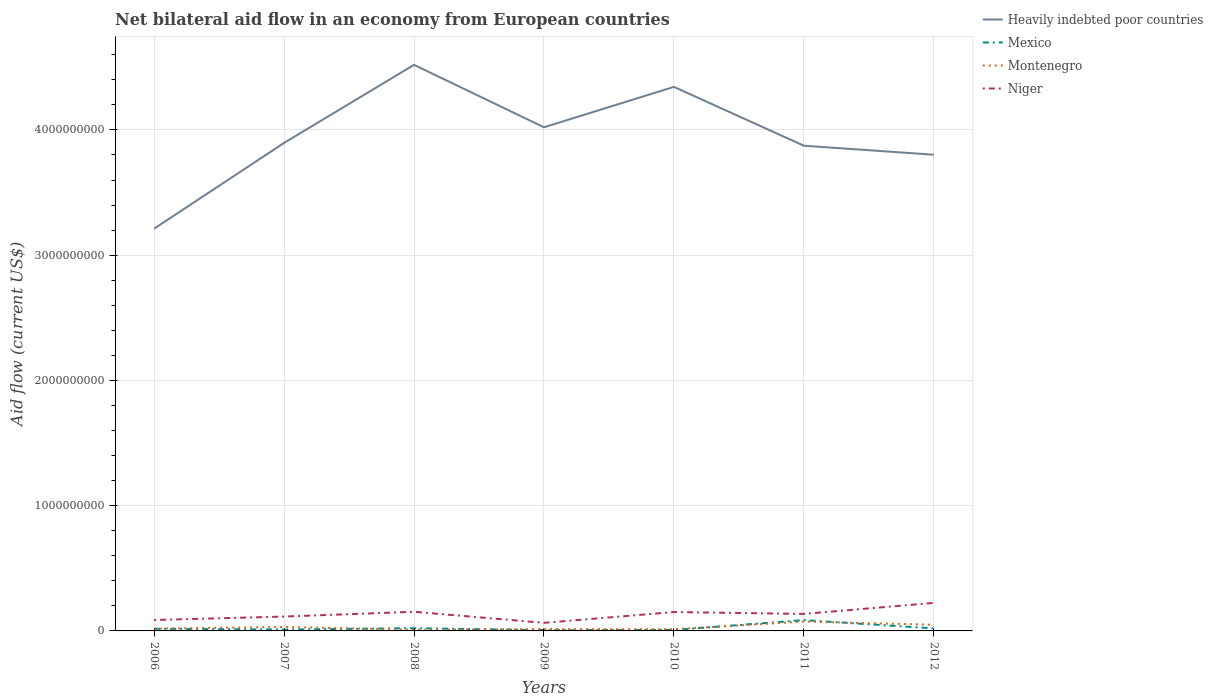Across all years, what is the maximum net bilateral aid flow in Heavily indebted poor countries?
Your answer should be compact. 3.21e+09. What is the total net bilateral aid flow in Niger in the graph?
Offer a very short reply. 8.84e+07. What is the difference between the highest and the second highest net bilateral aid flow in Montenegro?
Make the answer very short. 6.52e+07. What is the difference between the highest and the lowest net bilateral aid flow in Montenegro?
Your response must be concise. 3. Is the net bilateral aid flow in Heavily indebted poor countries strictly greater than the net bilateral aid flow in Niger over the years?
Make the answer very short. No. Does the graph contain any zero values?
Your answer should be very brief. No. Where does the legend appear in the graph?
Your answer should be compact. Top right. How many legend labels are there?
Make the answer very short. 4. How are the legend labels stacked?
Provide a succinct answer. Vertical. What is the title of the graph?
Ensure brevity in your answer.  Net bilateral aid flow in an economy from European countries. Does "Cabo Verde" appear as one of the legend labels in the graph?
Give a very brief answer. No. What is the Aid flow (current US$) in Heavily indebted poor countries in 2006?
Make the answer very short. 3.21e+09. What is the Aid flow (current US$) in Mexico in 2006?
Give a very brief answer. 1.73e+07. What is the Aid flow (current US$) of Montenegro in 2006?
Your answer should be compact. 1.81e+07. What is the Aid flow (current US$) in Niger in 2006?
Your answer should be compact. 8.72e+07. What is the Aid flow (current US$) of Heavily indebted poor countries in 2007?
Your answer should be compact. 3.90e+09. What is the Aid flow (current US$) in Mexico in 2007?
Offer a terse response. 1.09e+07. What is the Aid flow (current US$) in Montenegro in 2007?
Offer a very short reply. 3.16e+07. What is the Aid flow (current US$) of Niger in 2007?
Give a very brief answer. 1.15e+08. What is the Aid flow (current US$) in Heavily indebted poor countries in 2008?
Your answer should be very brief. 4.52e+09. What is the Aid flow (current US$) in Mexico in 2008?
Give a very brief answer. 2.17e+07. What is the Aid flow (current US$) of Montenegro in 2008?
Ensure brevity in your answer.  9.50e+06. What is the Aid flow (current US$) in Niger in 2008?
Make the answer very short. 1.53e+08. What is the Aid flow (current US$) of Heavily indebted poor countries in 2009?
Keep it short and to the point. 4.02e+09. What is the Aid flow (current US$) of Mexico in 2009?
Your answer should be very brief. 6.08e+06. What is the Aid flow (current US$) of Montenegro in 2009?
Give a very brief answer. 1.50e+07. What is the Aid flow (current US$) of Niger in 2009?
Provide a short and direct response. 6.44e+07. What is the Aid flow (current US$) of Heavily indebted poor countries in 2010?
Your answer should be very brief. 4.34e+09. What is the Aid flow (current US$) of Mexico in 2010?
Your answer should be compact. 7.51e+06. What is the Aid flow (current US$) of Montenegro in 2010?
Your answer should be very brief. 1.37e+07. What is the Aid flow (current US$) of Niger in 2010?
Provide a short and direct response. 1.51e+08. What is the Aid flow (current US$) in Heavily indebted poor countries in 2011?
Keep it short and to the point. 3.87e+09. What is the Aid flow (current US$) in Mexico in 2011?
Ensure brevity in your answer.  8.64e+07. What is the Aid flow (current US$) of Montenegro in 2011?
Give a very brief answer. 7.47e+07. What is the Aid flow (current US$) of Niger in 2011?
Make the answer very short. 1.36e+08. What is the Aid flow (current US$) in Heavily indebted poor countries in 2012?
Make the answer very short. 3.80e+09. What is the Aid flow (current US$) of Mexico in 2012?
Make the answer very short. 2.01e+07. What is the Aid flow (current US$) in Montenegro in 2012?
Offer a terse response. 4.91e+07. What is the Aid flow (current US$) in Niger in 2012?
Make the answer very short. 2.24e+08. Across all years, what is the maximum Aid flow (current US$) in Heavily indebted poor countries?
Provide a succinct answer. 4.52e+09. Across all years, what is the maximum Aid flow (current US$) in Mexico?
Keep it short and to the point. 8.64e+07. Across all years, what is the maximum Aid flow (current US$) in Montenegro?
Give a very brief answer. 7.47e+07. Across all years, what is the maximum Aid flow (current US$) of Niger?
Keep it short and to the point. 2.24e+08. Across all years, what is the minimum Aid flow (current US$) in Heavily indebted poor countries?
Provide a succinct answer. 3.21e+09. Across all years, what is the minimum Aid flow (current US$) of Mexico?
Ensure brevity in your answer.  6.08e+06. Across all years, what is the minimum Aid flow (current US$) of Montenegro?
Ensure brevity in your answer.  9.50e+06. Across all years, what is the minimum Aid flow (current US$) of Niger?
Give a very brief answer. 6.44e+07. What is the total Aid flow (current US$) in Heavily indebted poor countries in the graph?
Offer a very short reply. 2.77e+1. What is the total Aid flow (current US$) in Mexico in the graph?
Your answer should be very brief. 1.70e+08. What is the total Aid flow (current US$) of Montenegro in the graph?
Provide a short and direct response. 2.12e+08. What is the total Aid flow (current US$) in Niger in the graph?
Make the answer very short. 9.30e+08. What is the difference between the Aid flow (current US$) of Heavily indebted poor countries in 2006 and that in 2007?
Your response must be concise. -6.85e+08. What is the difference between the Aid flow (current US$) of Mexico in 2006 and that in 2007?
Make the answer very short. 6.42e+06. What is the difference between the Aid flow (current US$) in Montenegro in 2006 and that in 2007?
Give a very brief answer. -1.34e+07. What is the difference between the Aid flow (current US$) of Niger in 2006 and that in 2007?
Your answer should be compact. -2.75e+07. What is the difference between the Aid flow (current US$) in Heavily indebted poor countries in 2006 and that in 2008?
Offer a very short reply. -1.31e+09. What is the difference between the Aid flow (current US$) in Mexico in 2006 and that in 2008?
Your answer should be very brief. -4.39e+06. What is the difference between the Aid flow (current US$) in Montenegro in 2006 and that in 2008?
Offer a terse response. 8.63e+06. What is the difference between the Aid flow (current US$) in Niger in 2006 and that in 2008?
Keep it short and to the point. -6.57e+07. What is the difference between the Aid flow (current US$) in Heavily indebted poor countries in 2006 and that in 2009?
Offer a terse response. -8.09e+08. What is the difference between the Aid flow (current US$) of Mexico in 2006 and that in 2009?
Offer a terse response. 1.12e+07. What is the difference between the Aid flow (current US$) of Montenegro in 2006 and that in 2009?
Keep it short and to the point. 3.16e+06. What is the difference between the Aid flow (current US$) in Niger in 2006 and that in 2009?
Offer a terse response. 2.28e+07. What is the difference between the Aid flow (current US$) of Heavily indebted poor countries in 2006 and that in 2010?
Offer a very short reply. -1.13e+09. What is the difference between the Aid flow (current US$) in Mexico in 2006 and that in 2010?
Your response must be concise. 9.80e+06. What is the difference between the Aid flow (current US$) of Montenegro in 2006 and that in 2010?
Your answer should be very brief. 4.43e+06. What is the difference between the Aid flow (current US$) in Niger in 2006 and that in 2010?
Your answer should be compact. -6.36e+07. What is the difference between the Aid flow (current US$) in Heavily indebted poor countries in 2006 and that in 2011?
Offer a terse response. -6.62e+08. What is the difference between the Aid flow (current US$) in Mexico in 2006 and that in 2011?
Your answer should be compact. -6.91e+07. What is the difference between the Aid flow (current US$) in Montenegro in 2006 and that in 2011?
Make the answer very short. -5.66e+07. What is the difference between the Aid flow (current US$) in Niger in 2006 and that in 2011?
Provide a succinct answer. -4.85e+07. What is the difference between the Aid flow (current US$) in Heavily indebted poor countries in 2006 and that in 2012?
Your answer should be compact. -5.90e+08. What is the difference between the Aid flow (current US$) in Mexico in 2006 and that in 2012?
Provide a succinct answer. -2.81e+06. What is the difference between the Aid flow (current US$) of Montenegro in 2006 and that in 2012?
Your answer should be compact. -3.10e+07. What is the difference between the Aid flow (current US$) of Niger in 2006 and that in 2012?
Keep it short and to the point. -1.37e+08. What is the difference between the Aid flow (current US$) in Heavily indebted poor countries in 2007 and that in 2008?
Provide a succinct answer. -6.23e+08. What is the difference between the Aid flow (current US$) in Mexico in 2007 and that in 2008?
Give a very brief answer. -1.08e+07. What is the difference between the Aid flow (current US$) in Montenegro in 2007 and that in 2008?
Make the answer very short. 2.21e+07. What is the difference between the Aid flow (current US$) in Niger in 2007 and that in 2008?
Give a very brief answer. -3.82e+07. What is the difference between the Aid flow (current US$) of Heavily indebted poor countries in 2007 and that in 2009?
Ensure brevity in your answer.  -1.25e+08. What is the difference between the Aid flow (current US$) of Mexico in 2007 and that in 2009?
Make the answer very short. 4.81e+06. What is the difference between the Aid flow (current US$) of Montenegro in 2007 and that in 2009?
Offer a terse response. 1.66e+07. What is the difference between the Aid flow (current US$) of Niger in 2007 and that in 2009?
Keep it short and to the point. 5.03e+07. What is the difference between the Aid flow (current US$) of Heavily indebted poor countries in 2007 and that in 2010?
Your response must be concise. -4.47e+08. What is the difference between the Aid flow (current US$) in Mexico in 2007 and that in 2010?
Keep it short and to the point. 3.38e+06. What is the difference between the Aid flow (current US$) of Montenegro in 2007 and that in 2010?
Keep it short and to the point. 1.79e+07. What is the difference between the Aid flow (current US$) of Niger in 2007 and that in 2010?
Give a very brief answer. -3.61e+07. What is the difference between the Aid flow (current US$) in Heavily indebted poor countries in 2007 and that in 2011?
Provide a succinct answer. 2.26e+07. What is the difference between the Aid flow (current US$) in Mexico in 2007 and that in 2011?
Make the answer very short. -7.55e+07. What is the difference between the Aid flow (current US$) in Montenegro in 2007 and that in 2011?
Your answer should be very brief. -4.32e+07. What is the difference between the Aid flow (current US$) in Niger in 2007 and that in 2011?
Keep it short and to the point. -2.10e+07. What is the difference between the Aid flow (current US$) of Heavily indebted poor countries in 2007 and that in 2012?
Keep it short and to the point. 9.45e+07. What is the difference between the Aid flow (current US$) in Mexico in 2007 and that in 2012?
Ensure brevity in your answer.  -9.23e+06. What is the difference between the Aid flow (current US$) of Montenegro in 2007 and that in 2012?
Provide a short and direct response. -1.76e+07. What is the difference between the Aid flow (current US$) of Niger in 2007 and that in 2012?
Provide a short and direct response. -1.09e+08. What is the difference between the Aid flow (current US$) in Heavily indebted poor countries in 2008 and that in 2009?
Offer a very short reply. 4.98e+08. What is the difference between the Aid flow (current US$) of Mexico in 2008 and that in 2009?
Offer a very short reply. 1.56e+07. What is the difference between the Aid flow (current US$) of Montenegro in 2008 and that in 2009?
Offer a terse response. -5.47e+06. What is the difference between the Aid flow (current US$) in Niger in 2008 and that in 2009?
Your answer should be very brief. 8.84e+07. What is the difference between the Aid flow (current US$) of Heavily indebted poor countries in 2008 and that in 2010?
Keep it short and to the point. 1.76e+08. What is the difference between the Aid flow (current US$) in Mexico in 2008 and that in 2010?
Offer a terse response. 1.42e+07. What is the difference between the Aid flow (current US$) of Montenegro in 2008 and that in 2010?
Ensure brevity in your answer.  -4.20e+06. What is the difference between the Aid flow (current US$) in Niger in 2008 and that in 2010?
Provide a succinct answer. 2.10e+06. What is the difference between the Aid flow (current US$) in Heavily indebted poor countries in 2008 and that in 2011?
Provide a short and direct response. 6.46e+08. What is the difference between the Aid flow (current US$) of Mexico in 2008 and that in 2011?
Provide a short and direct response. -6.47e+07. What is the difference between the Aid flow (current US$) of Montenegro in 2008 and that in 2011?
Your answer should be compact. -6.52e+07. What is the difference between the Aid flow (current US$) of Niger in 2008 and that in 2011?
Your answer should be compact. 1.72e+07. What is the difference between the Aid flow (current US$) in Heavily indebted poor countries in 2008 and that in 2012?
Your response must be concise. 7.18e+08. What is the difference between the Aid flow (current US$) in Mexico in 2008 and that in 2012?
Your response must be concise. 1.58e+06. What is the difference between the Aid flow (current US$) of Montenegro in 2008 and that in 2012?
Provide a short and direct response. -3.96e+07. What is the difference between the Aid flow (current US$) in Niger in 2008 and that in 2012?
Keep it short and to the point. -7.10e+07. What is the difference between the Aid flow (current US$) of Heavily indebted poor countries in 2009 and that in 2010?
Ensure brevity in your answer.  -3.23e+08. What is the difference between the Aid flow (current US$) in Mexico in 2009 and that in 2010?
Offer a very short reply. -1.43e+06. What is the difference between the Aid flow (current US$) in Montenegro in 2009 and that in 2010?
Your answer should be compact. 1.27e+06. What is the difference between the Aid flow (current US$) in Niger in 2009 and that in 2010?
Keep it short and to the point. -8.64e+07. What is the difference between the Aid flow (current US$) of Heavily indebted poor countries in 2009 and that in 2011?
Make the answer very short. 1.47e+08. What is the difference between the Aid flow (current US$) of Mexico in 2009 and that in 2011?
Give a very brief answer. -8.03e+07. What is the difference between the Aid flow (current US$) in Montenegro in 2009 and that in 2011?
Give a very brief answer. -5.98e+07. What is the difference between the Aid flow (current US$) in Niger in 2009 and that in 2011?
Make the answer very short. -7.13e+07. What is the difference between the Aid flow (current US$) in Heavily indebted poor countries in 2009 and that in 2012?
Your answer should be compact. 2.19e+08. What is the difference between the Aid flow (current US$) of Mexico in 2009 and that in 2012?
Your answer should be compact. -1.40e+07. What is the difference between the Aid flow (current US$) in Montenegro in 2009 and that in 2012?
Give a very brief answer. -3.42e+07. What is the difference between the Aid flow (current US$) in Niger in 2009 and that in 2012?
Your answer should be compact. -1.59e+08. What is the difference between the Aid flow (current US$) in Heavily indebted poor countries in 2010 and that in 2011?
Ensure brevity in your answer.  4.70e+08. What is the difference between the Aid flow (current US$) of Mexico in 2010 and that in 2011?
Give a very brief answer. -7.89e+07. What is the difference between the Aid flow (current US$) of Montenegro in 2010 and that in 2011?
Offer a very short reply. -6.10e+07. What is the difference between the Aid flow (current US$) in Niger in 2010 and that in 2011?
Keep it short and to the point. 1.51e+07. What is the difference between the Aid flow (current US$) of Heavily indebted poor countries in 2010 and that in 2012?
Offer a very short reply. 5.42e+08. What is the difference between the Aid flow (current US$) of Mexico in 2010 and that in 2012?
Make the answer very short. -1.26e+07. What is the difference between the Aid flow (current US$) in Montenegro in 2010 and that in 2012?
Your answer should be very brief. -3.54e+07. What is the difference between the Aid flow (current US$) in Niger in 2010 and that in 2012?
Give a very brief answer. -7.30e+07. What is the difference between the Aid flow (current US$) in Heavily indebted poor countries in 2011 and that in 2012?
Your answer should be very brief. 7.20e+07. What is the difference between the Aid flow (current US$) of Mexico in 2011 and that in 2012?
Offer a terse response. 6.63e+07. What is the difference between the Aid flow (current US$) in Montenegro in 2011 and that in 2012?
Keep it short and to the point. 2.56e+07. What is the difference between the Aid flow (current US$) of Niger in 2011 and that in 2012?
Give a very brief answer. -8.81e+07. What is the difference between the Aid flow (current US$) of Heavily indebted poor countries in 2006 and the Aid flow (current US$) of Mexico in 2007?
Offer a terse response. 3.20e+09. What is the difference between the Aid flow (current US$) of Heavily indebted poor countries in 2006 and the Aid flow (current US$) of Montenegro in 2007?
Ensure brevity in your answer.  3.18e+09. What is the difference between the Aid flow (current US$) in Heavily indebted poor countries in 2006 and the Aid flow (current US$) in Niger in 2007?
Give a very brief answer. 3.10e+09. What is the difference between the Aid flow (current US$) of Mexico in 2006 and the Aid flow (current US$) of Montenegro in 2007?
Your answer should be compact. -1.43e+07. What is the difference between the Aid flow (current US$) of Mexico in 2006 and the Aid flow (current US$) of Niger in 2007?
Provide a short and direct response. -9.74e+07. What is the difference between the Aid flow (current US$) in Montenegro in 2006 and the Aid flow (current US$) in Niger in 2007?
Provide a short and direct response. -9.66e+07. What is the difference between the Aid flow (current US$) of Heavily indebted poor countries in 2006 and the Aid flow (current US$) of Mexico in 2008?
Offer a very short reply. 3.19e+09. What is the difference between the Aid flow (current US$) of Heavily indebted poor countries in 2006 and the Aid flow (current US$) of Montenegro in 2008?
Your answer should be compact. 3.20e+09. What is the difference between the Aid flow (current US$) of Heavily indebted poor countries in 2006 and the Aid flow (current US$) of Niger in 2008?
Offer a terse response. 3.06e+09. What is the difference between the Aid flow (current US$) in Mexico in 2006 and the Aid flow (current US$) in Montenegro in 2008?
Keep it short and to the point. 7.81e+06. What is the difference between the Aid flow (current US$) in Mexico in 2006 and the Aid flow (current US$) in Niger in 2008?
Your answer should be very brief. -1.36e+08. What is the difference between the Aid flow (current US$) in Montenegro in 2006 and the Aid flow (current US$) in Niger in 2008?
Offer a very short reply. -1.35e+08. What is the difference between the Aid flow (current US$) in Heavily indebted poor countries in 2006 and the Aid flow (current US$) in Mexico in 2009?
Give a very brief answer. 3.21e+09. What is the difference between the Aid flow (current US$) in Heavily indebted poor countries in 2006 and the Aid flow (current US$) in Montenegro in 2009?
Give a very brief answer. 3.20e+09. What is the difference between the Aid flow (current US$) in Heavily indebted poor countries in 2006 and the Aid flow (current US$) in Niger in 2009?
Give a very brief answer. 3.15e+09. What is the difference between the Aid flow (current US$) in Mexico in 2006 and the Aid flow (current US$) in Montenegro in 2009?
Your answer should be very brief. 2.34e+06. What is the difference between the Aid flow (current US$) in Mexico in 2006 and the Aid flow (current US$) in Niger in 2009?
Give a very brief answer. -4.71e+07. What is the difference between the Aid flow (current US$) of Montenegro in 2006 and the Aid flow (current US$) of Niger in 2009?
Ensure brevity in your answer.  -4.63e+07. What is the difference between the Aid flow (current US$) in Heavily indebted poor countries in 2006 and the Aid flow (current US$) in Mexico in 2010?
Offer a very short reply. 3.20e+09. What is the difference between the Aid flow (current US$) of Heavily indebted poor countries in 2006 and the Aid flow (current US$) of Montenegro in 2010?
Provide a succinct answer. 3.20e+09. What is the difference between the Aid flow (current US$) of Heavily indebted poor countries in 2006 and the Aid flow (current US$) of Niger in 2010?
Provide a short and direct response. 3.06e+09. What is the difference between the Aid flow (current US$) of Mexico in 2006 and the Aid flow (current US$) of Montenegro in 2010?
Offer a terse response. 3.61e+06. What is the difference between the Aid flow (current US$) in Mexico in 2006 and the Aid flow (current US$) in Niger in 2010?
Keep it short and to the point. -1.33e+08. What is the difference between the Aid flow (current US$) in Montenegro in 2006 and the Aid flow (current US$) in Niger in 2010?
Offer a very short reply. -1.33e+08. What is the difference between the Aid flow (current US$) in Heavily indebted poor countries in 2006 and the Aid flow (current US$) in Mexico in 2011?
Provide a short and direct response. 3.13e+09. What is the difference between the Aid flow (current US$) in Heavily indebted poor countries in 2006 and the Aid flow (current US$) in Montenegro in 2011?
Make the answer very short. 3.14e+09. What is the difference between the Aid flow (current US$) of Heavily indebted poor countries in 2006 and the Aid flow (current US$) of Niger in 2011?
Provide a succinct answer. 3.08e+09. What is the difference between the Aid flow (current US$) in Mexico in 2006 and the Aid flow (current US$) in Montenegro in 2011?
Keep it short and to the point. -5.74e+07. What is the difference between the Aid flow (current US$) of Mexico in 2006 and the Aid flow (current US$) of Niger in 2011?
Your answer should be compact. -1.18e+08. What is the difference between the Aid flow (current US$) in Montenegro in 2006 and the Aid flow (current US$) in Niger in 2011?
Make the answer very short. -1.18e+08. What is the difference between the Aid flow (current US$) in Heavily indebted poor countries in 2006 and the Aid flow (current US$) in Mexico in 2012?
Give a very brief answer. 3.19e+09. What is the difference between the Aid flow (current US$) of Heavily indebted poor countries in 2006 and the Aid flow (current US$) of Montenegro in 2012?
Offer a terse response. 3.16e+09. What is the difference between the Aid flow (current US$) of Heavily indebted poor countries in 2006 and the Aid flow (current US$) of Niger in 2012?
Give a very brief answer. 2.99e+09. What is the difference between the Aid flow (current US$) of Mexico in 2006 and the Aid flow (current US$) of Montenegro in 2012?
Your answer should be very brief. -3.18e+07. What is the difference between the Aid flow (current US$) in Mexico in 2006 and the Aid flow (current US$) in Niger in 2012?
Provide a short and direct response. -2.07e+08. What is the difference between the Aid flow (current US$) of Montenegro in 2006 and the Aid flow (current US$) of Niger in 2012?
Your response must be concise. -2.06e+08. What is the difference between the Aid flow (current US$) of Heavily indebted poor countries in 2007 and the Aid flow (current US$) of Mexico in 2008?
Provide a succinct answer. 3.87e+09. What is the difference between the Aid flow (current US$) of Heavily indebted poor countries in 2007 and the Aid flow (current US$) of Montenegro in 2008?
Offer a terse response. 3.89e+09. What is the difference between the Aid flow (current US$) in Heavily indebted poor countries in 2007 and the Aid flow (current US$) in Niger in 2008?
Your answer should be very brief. 3.74e+09. What is the difference between the Aid flow (current US$) in Mexico in 2007 and the Aid flow (current US$) in Montenegro in 2008?
Offer a very short reply. 1.39e+06. What is the difference between the Aid flow (current US$) in Mexico in 2007 and the Aid flow (current US$) in Niger in 2008?
Keep it short and to the point. -1.42e+08. What is the difference between the Aid flow (current US$) of Montenegro in 2007 and the Aid flow (current US$) of Niger in 2008?
Provide a succinct answer. -1.21e+08. What is the difference between the Aid flow (current US$) in Heavily indebted poor countries in 2007 and the Aid flow (current US$) in Mexico in 2009?
Give a very brief answer. 3.89e+09. What is the difference between the Aid flow (current US$) in Heavily indebted poor countries in 2007 and the Aid flow (current US$) in Montenegro in 2009?
Provide a short and direct response. 3.88e+09. What is the difference between the Aid flow (current US$) of Heavily indebted poor countries in 2007 and the Aid flow (current US$) of Niger in 2009?
Provide a short and direct response. 3.83e+09. What is the difference between the Aid flow (current US$) in Mexico in 2007 and the Aid flow (current US$) in Montenegro in 2009?
Offer a very short reply. -4.08e+06. What is the difference between the Aid flow (current US$) in Mexico in 2007 and the Aid flow (current US$) in Niger in 2009?
Your answer should be very brief. -5.36e+07. What is the difference between the Aid flow (current US$) of Montenegro in 2007 and the Aid flow (current US$) of Niger in 2009?
Provide a short and direct response. -3.29e+07. What is the difference between the Aid flow (current US$) of Heavily indebted poor countries in 2007 and the Aid flow (current US$) of Mexico in 2010?
Ensure brevity in your answer.  3.89e+09. What is the difference between the Aid flow (current US$) of Heavily indebted poor countries in 2007 and the Aid flow (current US$) of Montenegro in 2010?
Keep it short and to the point. 3.88e+09. What is the difference between the Aid flow (current US$) in Heavily indebted poor countries in 2007 and the Aid flow (current US$) in Niger in 2010?
Offer a terse response. 3.75e+09. What is the difference between the Aid flow (current US$) in Mexico in 2007 and the Aid flow (current US$) in Montenegro in 2010?
Offer a terse response. -2.81e+06. What is the difference between the Aid flow (current US$) of Mexico in 2007 and the Aid flow (current US$) of Niger in 2010?
Your answer should be very brief. -1.40e+08. What is the difference between the Aid flow (current US$) of Montenegro in 2007 and the Aid flow (current US$) of Niger in 2010?
Keep it short and to the point. -1.19e+08. What is the difference between the Aid flow (current US$) in Heavily indebted poor countries in 2007 and the Aid flow (current US$) in Mexico in 2011?
Your response must be concise. 3.81e+09. What is the difference between the Aid flow (current US$) of Heavily indebted poor countries in 2007 and the Aid flow (current US$) of Montenegro in 2011?
Provide a succinct answer. 3.82e+09. What is the difference between the Aid flow (current US$) of Heavily indebted poor countries in 2007 and the Aid flow (current US$) of Niger in 2011?
Make the answer very short. 3.76e+09. What is the difference between the Aid flow (current US$) of Mexico in 2007 and the Aid flow (current US$) of Montenegro in 2011?
Give a very brief answer. -6.38e+07. What is the difference between the Aid flow (current US$) of Mexico in 2007 and the Aid flow (current US$) of Niger in 2011?
Your answer should be compact. -1.25e+08. What is the difference between the Aid flow (current US$) of Montenegro in 2007 and the Aid flow (current US$) of Niger in 2011?
Ensure brevity in your answer.  -1.04e+08. What is the difference between the Aid flow (current US$) of Heavily indebted poor countries in 2007 and the Aid flow (current US$) of Mexico in 2012?
Provide a succinct answer. 3.88e+09. What is the difference between the Aid flow (current US$) in Heavily indebted poor countries in 2007 and the Aid flow (current US$) in Montenegro in 2012?
Offer a terse response. 3.85e+09. What is the difference between the Aid flow (current US$) in Heavily indebted poor countries in 2007 and the Aid flow (current US$) in Niger in 2012?
Offer a very short reply. 3.67e+09. What is the difference between the Aid flow (current US$) of Mexico in 2007 and the Aid flow (current US$) of Montenegro in 2012?
Offer a very short reply. -3.82e+07. What is the difference between the Aid flow (current US$) in Mexico in 2007 and the Aid flow (current US$) in Niger in 2012?
Give a very brief answer. -2.13e+08. What is the difference between the Aid flow (current US$) in Montenegro in 2007 and the Aid flow (current US$) in Niger in 2012?
Give a very brief answer. -1.92e+08. What is the difference between the Aid flow (current US$) in Heavily indebted poor countries in 2008 and the Aid flow (current US$) in Mexico in 2009?
Keep it short and to the point. 4.51e+09. What is the difference between the Aid flow (current US$) in Heavily indebted poor countries in 2008 and the Aid flow (current US$) in Montenegro in 2009?
Your answer should be very brief. 4.50e+09. What is the difference between the Aid flow (current US$) of Heavily indebted poor countries in 2008 and the Aid flow (current US$) of Niger in 2009?
Make the answer very short. 4.46e+09. What is the difference between the Aid flow (current US$) in Mexico in 2008 and the Aid flow (current US$) in Montenegro in 2009?
Provide a short and direct response. 6.73e+06. What is the difference between the Aid flow (current US$) in Mexico in 2008 and the Aid flow (current US$) in Niger in 2009?
Provide a succinct answer. -4.27e+07. What is the difference between the Aid flow (current US$) in Montenegro in 2008 and the Aid flow (current US$) in Niger in 2009?
Provide a succinct answer. -5.49e+07. What is the difference between the Aid flow (current US$) of Heavily indebted poor countries in 2008 and the Aid flow (current US$) of Mexico in 2010?
Your answer should be very brief. 4.51e+09. What is the difference between the Aid flow (current US$) in Heavily indebted poor countries in 2008 and the Aid flow (current US$) in Montenegro in 2010?
Make the answer very short. 4.51e+09. What is the difference between the Aid flow (current US$) in Heavily indebted poor countries in 2008 and the Aid flow (current US$) in Niger in 2010?
Offer a very short reply. 4.37e+09. What is the difference between the Aid flow (current US$) of Mexico in 2008 and the Aid flow (current US$) of Niger in 2010?
Provide a short and direct response. -1.29e+08. What is the difference between the Aid flow (current US$) in Montenegro in 2008 and the Aid flow (current US$) in Niger in 2010?
Your answer should be compact. -1.41e+08. What is the difference between the Aid flow (current US$) in Heavily indebted poor countries in 2008 and the Aid flow (current US$) in Mexico in 2011?
Keep it short and to the point. 4.43e+09. What is the difference between the Aid flow (current US$) of Heavily indebted poor countries in 2008 and the Aid flow (current US$) of Montenegro in 2011?
Give a very brief answer. 4.44e+09. What is the difference between the Aid flow (current US$) in Heavily indebted poor countries in 2008 and the Aid flow (current US$) in Niger in 2011?
Your answer should be very brief. 4.38e+09. What is the difference between the Aid flow (current US$) of Mexico in 2008 and the Aid flow (current US$) of Montenegro in 2011?
Your answer should be compact. -5.30e+07. What is the difference between the Aid flow (current US$) of Mexico in 2008 and the Aid flow (current US$) of Niger in 2011?
Offer a very short reply. -1.14e+08. What is the difference between the Aid flow (current US$) of Montenegro in 2008 and the Aid flow (current US$) of Niger in 2011?
Keep it short and to the point. -1.26e+08. What is the difference between the Aid flow (current US$) of Heavily indebted poor countries in 2008 and the Aid flow (current US$) of Mexico in 2012?
Your answer should be compact. 4.50e+09. What is the difference between the Aid flow (current US$) of Heavily indebted poor countries in 2008 and the Aid flow (current US$) of Montenegro in 2012?
Your response must be concise. 4.47e+09. What is the difference between the Aid flow (current US$) in Heavily indebted poor countries in 2008 and the Aid flow (current US$) in Niger in 2012?
Provide a succinct answer. 4.30e+09. What is the difference between the Aid flow (current US$) of Mexico in 2008 and the Aid flow (current US$) of Montenegro in 2012?
Provide a short and direct response. -2.74e+07. What is the difference between the Aid flow (current US$) in Mexico in 2008 and the Aid flow (current US$) in Niger in 2012?
Your answer should be compact. -2.02e+08. What is the difference between the Aid flow (current US$) in Montenegro in 2008 and the Aid flow (current US$) in Niger in 2012?
Keep it short and to the point. -2.14e+08. What is the difference between the Aid flow (current US$) in Heavily indebted poor countries in 2009 and the Aid flow (current US$) in Mexico in 2010?
Provide a short and direct response. 4.01e+09. What is the difference between the Aid flow (current US$) of Heavily indebted poor countries in 2009 and the Aid flow (current US$) of Montenegro in 2010?
Your answer should be compact. 4.01e+09. What is the difference between the Aid flow (current US$) in Heavily indebted poor countries in 2009 and the Aid flow (current US$) in Niger in 2010?
Provide a succinct answer. 3.87e+09. What is the difference between the Aid flow (current US$) in Mexico in 2009 and the Aid flow (current US$) in Montenegro in 2010?
Your answer should be compact. -7.62e+06. What is the difference between the Aid flow (current US$) in Mexico in 2009 and the Aid flow (current US$) in Niger in 2010?
Make the answer very short. -1.45e+08. What is the difference between the Aid flow (current US$) in Montenegro in 2009 and the Aid flow (current US$) in Niger in 2010?
Ensure brevity in your answer.  -1.36e+08. What is the difference between the Aid flow (current US$) in Heavily indebted poor countries in 2009 and the Aid flow (current US$) in Mexico in 2011?
Your answer should be compact. 3.93e+09. What is the difference between the Aid flow (current US$) in Heavily indebted poor countries in 2009 and the Aid flow (current US$) in Montenegro in 2011?
Offer a very short reply. 3.95e+09. What is the difference between the Aid flow (current US$) in Heavily indebted poor countries in 2009 and the Aid flow (current US$) in Niger in 2011?
Ensure brevity in your answer.  3.89e+09. What is the difference between the Aid flow (current US$) in Mexico in 2009 and the Aid flow (current US$) in Montenegro in 2011?
Your answer should be compact. -6.86e+07. What is the difference between the Aid flow (current US$) of Mexico in 2009 and the Aid flow (current US$) of Niger in 2011?
Provide a short and direct response. -1.30e+08. What is the difference between the Aid flow (current US$) of Montenegro in 2009 and the Aid flow (current US$) of Niger in 2011?
Offer a very short reply. -1.21e+08. What is the difference between the Aid flow (current US$) in Heavily indebted poor countries in 2009 and the Aid flow (current US$) in Mexico in 2012?
Provide a short and direct response. 4.00e+09. What is the difference between the Aid flow (current US$) in Heavily indebted poor countries in 2009 and the Aid flow (current US$) in Montenegro in 2012?
Your answer should be very brief. 3.97e+09. What is the difference between the Aid flow (current US$) in Heavily indebted poor countries in 2009 and the Aid flow (current US$) in Niger in 2012?
Your answer should be very brief. 3.80e+09. What is the difference between the Aid flow (current US$) of Mexico in 2009 and the Aid flow (current US$) of Montenegro in 2012?
Ensure brevity in your answer.  -4.31e+07. What is the difference between the Aid flow (current US$) of Mexico in 2009 and the Aid flow (current US$) of Niger in 2012?
Your answer should be very brief. -2.18e+08. What is the difference between the Aid flow (current US$) in Montenegro in 2009 and the Aid flow (current US$) in Niger in 2012?
Keep it short and to the point. -2.09e+08. What is the difference between the Aid flow (current US$) of Heavily indebted poor countries in 2010 and the Aid flow (current US$) of Mexico in 2011?
Keep it short and to the point. 4.26e+09. What is the difference between the Aid flow (current US$) of Heavily indebted poor countries in 2010 and the Aid flow (current US$) of Montenegro in 2011?
Ensure brevity in your answer.  4.27e+09. What is the difference between the Aid flow (current US$) in Heavily indebted poor countries in 2010 and the Aid flow (current US$) in Niger in 2011?
Your response must be concise. 4.21e+09. What is the difference between the Aid flow (current US$) of Mexico in 2010 and the Aid flow (current US$) of Montenegro in 2011?
Give a very brief answer. -6.72e+07. What is the difference between the Aid flow (current US$) of Mexico in 2010 and the Aid flow (current US$) of Niger in 2011?
Your answer should be compact. -1.28e+08. What is the difference between the Aid flow (current US$) in Montenegro in 2010 and the Aid flow (current US$) in Niger in 2011?
Your answer should be compact. -1.22e+08. What is the difference between the Aid flow (current US$) of Heavily indebted poor countries in 2010 and the Aid flow (current US$) of Mexico in 2012?
Your answer should be very brief. 4.32e+09. What is the difference between the Aid flow (current US$) in Heavily indebted poor countries in 2010 and the Aid flow (current US$) in Montenegro in 2012?
Provide a succinct answer. 4.29e+09. What is the difference between the Aid flow (current US$) in Heavily indebted poor countries in 2010 and the Aid flow (current US$) in Niger in 2012?
Keep it short and to the point. 4.12e+09. What is the difference between the Aid flow (current US$) in Mexico in 2010 and the Aid flow (current US$) in Montenegro in 2012?
Provide a short and direct response. -4.16e+07. What is the difference between the Aid flow (current US$) of Mexico in 2010 and the Aid flow (current US$) of Niger in 2012?
Provide a short and direct response. -2.16e+08. What is the difference between the Aid flow (current US$) in Montenegro in 2010 and the Aid flow (current US$) in Niger in 2012?
Give a very brief answer. -2.10e+08. What is the difference between the Aid flow (current US$) in Heavily indebted poor countries in 2011 and the Aid flow (current US$) in Mexico in 2012?
Keep it short and to the point. 3.85e+09. What is the difference between the Aid flow (current US$) of Heavily indebted poor countries in 2011 and the Aid flow (current US$) of Montenegro in 2012?
Make the answer very short. 3.82e+09. What is the difference between the Aid flow (current US$) of Heavily indebted poor countries in 2011 and the Aid flow (current US$) of Niger in 2012?
Your response must be concise. 3.65e+09. What is the difference between the Aid flow (current US$) in Mexico in 2011 and the Aid flow (current US$) in Montenegro in 2012?
Your response must be concise. 3.73e+07. What is the difference between the Aid flow (current US$) in Mexico in 2011 and the Aid flow (current US$) in Niger in 2012?
Give a very brief answer. -1.37e+08. What is the difference between the Aid flow (current US$) of Montenegro in 2011 and the Aid flow (current US$) of Niger in 2012?
Give a very brief answer. -1.49e+08. What is the average Aid flow (current US$) in Heavily indebted poor countries per year?
Provide a succinct answer. 3.95e+09. What is the average Aid flow (current US$) of Mexico per year?
Provide a short and direct response. 2.43e+07. What is the average Aid flow (current US$) of Montenegro per year?
Make the answer very short. 3.02e+07. What is the average Aid flow (current US$) in Niger per year?
Your answer should be very brief. 1.33e+08. In the year 2006, what is the difference between the Aid flow (current US$) of Heavily indebted poor countries and Aid flow (current US$) of Mexico?
Keep it short and to the point. 3.19e+09. In the year 2006, what is the difference between the Aid flow (current US$) of Heavily indebted poor countries and Aid flow (current US$) of Montenegro?
Offer a very short reply. 3.19e+09. In the year 2006, what is the difference between the Aid flow (current US$) in Heavily indebted poor countries and Aid flow (current US$) in Niger?
Offer a terse response. 3.12e+09. In the year 2006, what is the difference between the Aid flow (current US$) in Mexico and Aid flow (current US$) in Montenegro?
Keep it short and to the point. -8.20e+05. In the year 2006, what is the difference between the Aid flow (current US$) in Mexico and Aid flow (current US$) in Niger?
Your answer should be very brief. -6.99e+07. In the year 2006, what is the difference between the Aid flow (current US$) in Montenegro and Aid flow (current US$) in Niger?
Your response must be concise. -6.91e+07. In the year 2007, what is the difference between the Aid flow (current US$) of Heavily indebted poor countries and Aid flow (current US$) of Mexico?
Offer a very short reply. 3.89e+09. In the year 2007, what is the difference between the Aid flow (current US$) of Heavily indebted poor countries and Aid flow (current US$) of Montenegro?
Your answer should be very brief. 3.86e+09. In the year 2007, what is the difference between the Aid flow (current US$) of Heavily indebted poor countries and Aid flow (current US$) of Niger?
Provide a succinct answer. 3.78e+09. In the year 2007, what is the difference between the Aid flow (current US$) of Mexico and Aid flow (current US$) of Montenegro?
Your response must be concise. -2.07e+07. In the year 2007, what is the difference between the Aid flow (current US$) in Mexico and Aid flow (current US$) in Niger?
Make the answer very short. -1.04e+08. In the year 2007, what is the difference between the Aid flow (current US$) in Montenegro and Aid flow (current US$) in Niger?
Your answer should be very brief. -8.31e+07. In the year 2008, what is the difference between the Aid flow (current US$) in Heavily indebted poor countries and Aid flow (current US$) in Mexico?
Keep it short and to the point. 4.50e+09. In the year 2008, what is the difference between the Aid flow (current US$) of Heavily indebted poor countries and Aid flow (current US$) of Montenegro?
Keep it short and to the point. 4.51e+09. In the year 2008, what is the difference between the Aid flow (current US$) of Heavily indebted poor countries and Aid flow (current US$) of Niger?
Your answer should be compact. 4.37e+09. In the year 2008, what is the difference between the Aid flow (current US$) of Mexico and Aid flow (current US$) of Montenegro?
Make the answer very short. 1.22e+07. In the year 2008, what is the difference between the Aid flow (current US$) of Mexico and Aid flow (current US$) of Niger?
Keep it short and to the point. -1.31e+08. In the year 2008, what is the difference between the Aid flow (current US$) in Montenegro and Aid flow (current US$) in Niger?
Give a very brief answer. -1.43e+08. In the year 2009, what is the difference between the Aid flow (current US$) of Heavily indebted poor countries and Aid flow (current US$) of Mexico?
Your response must be concise. 4.01e+09. In the year 2009, what is the difference between the Aid flow (current US$) of Heavily indebted poor countries and Aid flow (current US$) of Montenegro?
Keep it short and to the point. 4.01e+09. In the year 2009, what is the difference between the Aid flow (current US$) in Heavily indebted poor countries and Aid flow (current US$) in Niger?
Your response must be concise. 3.96e+09. In the year 2009, what is the difference between the Aid flow (current US$) in Mexico and Aid flow (current US$) in Montenegro?
Give a very brief answer. -8.89e+06. In the year 2009, what is the difference between the Aid flow (current US$) in Mexico and Aid flow (current US$) in Niger?
Ensure brevity in your answer.  -5.84e+07. In the year 2009, what is the difference between the Aid flow (current US$) of Montenegro and Aid flow (current US$) of Niger?
Make the answer very short. -4.95e+07. In the year 2010, what is the difference between the Aid flow (current US$) of Heavily indebted poor countries and Aid flow (current US$) of Mexico?
Your answer should be compact. 4.34e+09. In the year 2010, what is the difference between the Aid flow (current US$) in Heavily indebted poor countries and Aid flow (current US$) in Montenegro?
Keep it short and to the point. 4.33e+09. In the year 2010, what is the difference between the Aid flow (current US$) of Heavily indebted poor countries and Aid flow (current US$) of Niger?
Make the answer very short. 4.19e+09. In the year 2010, what is the difference between the Aid flow (current US$) of Mexico and Aid flow (current US$) of Montenegro?
Make the answer very short. -6.19e+06. In the year 2010, what is the difference between the Aid flow (current US$) of Mexico and Aid flow (current US$) of Niger?
Your answer should be compact. -1.43e+08. In the year 2010, what is the difference between the Aid flow (current US$) in Montenegro and Aid flow (current US$) in Niger?
Keep it short and to the point. -1.37e+08. In the year 2011, what is the difference between the Aid flow (current US$) in Heavily indebted poor countries and Aid flow (current US$) in Mexico?
Ensure brevity in your answer.  3.79e+09. In the year 2011, what is the difference between the Aid flow (current US$) in Heavily indebted poor countries and Aid flow (current US$) in Montenegro?
Offer a very short reply. 3.80e+09. In the year 2011, what is the difference between the Aid flow (current US$) in Heavily indebted poor countries and Aid flow (current US$) in Niger?
Ensure brevity in your answer.  3.74e+09. In the year 2011, what is the difference between the Aid flow (current US$) in Mexico and Aid flow (current US$) in Montenegro?
Keep it short and to the point. 1.17e+07. In the year 2011, what is the difference between the Aid flow (current US$) in Mexico and Aid flow (current US$) in Niger?
Ensure brevity in your answer.  -4.93e+07. In the year 2011, what is the difference between the Aid flow (current US$) in Montenegro and Aid flow (current US$) in Niger?
Your response must be concise. -6.10e+07. In the year 2012, what is the difference between the Aid flow (current US$) of Heavily indebted poor countries and Aid flow (current US$) of Mexico?
Make the answer very short. 3.78e+09. In the year 2012, what is the difference between the Aid flow (current US$) of Heavily indebted poor countries and Aid flow (current US$) of Montenegro?
Your answer should be compact. 3.75e+09. In the year 2012, what is the difference between the Aid flow (current US$) of Heavily indebted poor countries and Aid flow (current US$) of Niger?
Offer a terse response. 3.58e+09. In the year 2012, what is the difference between the Aid flow (current US$) of Mexico and Aid flow (current US$) of Montenegro?
Offer a terse response. -2.90e+07. In the year 2012, what is the difference between the Aid flow (current US$) in Mexico and Aid flow (current US$) in Niger?
Keep it short and to the point. -2.04e+08. In the year 2012, what is the difference between the Aid flow (current US$) in Montenegro and Aid flow (current US$) in Niger?
Ensure brevity in your answer.  -1.75e+08. What is the ratio of the Aid flow (current US$) in Heavily indebted poor countries in 2006 to that in 2007?
Your answer should be compact. 0.82. What is the ratio of the Aid flow (current US$) of Mexico in 2006 to that in 2007?
Offer a very short reply. 1.59. What is the ratio of the Aid flow (current US$) in Montenegro in 2006 to that in 2007?
Offer a very short reply. 0.57. What is the ratio of the Aid flow (current US$) in Niger in 2006 to that in 2007?
Your answer should be compact. 0.76. What is the ratio of the Aid flow (current US$) in Heavily indebted poor countries in 2006 to that in 2008?
Offer a terse response. 0.71. What is the ratio of the Aid flow (current US$) in Mexico in 2006 to that in 2008?
Your answer should be compact. 0.8. What is the ratio of the Aid flow (current US$) of Montenegro in 2006 to that in 2008?
Keep it short and to the point. 1.91. What is the ratio of the Aid flow (current US$) in Niger in 2006 to that in 2008?
Give a very brief answer. 0.57. What is the ratio of the Aid flow (current US$) in Heavily indebted poor countries in 2006 to that in 2009?
Provide a short and direct response. 0.8. What is the ratio of the Aid flow (current US$) in Mexico in 2006 to that in 2009?
Your response must be concise. 2.85. What is the ratio of the Aid flow (current US$) in Montenegro in 2006 to that in 2009?
Provide a short and direct response. 1.21. What is the ratio of the Aid flow (current US$) in Niger in 2006 to that in 2009?
Give a very brief answer. 1.35. What is the ratio of the Aid flow (current US$) in Heavily indebted poor countries in 2006 to that in 2010?
Offer a terse response. 0.74. What is the ratio of the Aid flow (current US$) in Mexico in 2006 to that in 2010?
Make the answer very short. 2.3. What is the ratio of the Aid flow (current US$) of Montenegro in 2006 to that in 2010?
Your answer should be very brief. 1.32. What is the ratio of the Aid flow (current US$) of Niger in 2006 to that in 2010?
Provide a succinct answer. 0.58. What is the ratio of the Aid flow (current US$) in Heavily indebted poor countries in 2006 to that in 2011?
Your answer should be compact. 0.83. What is the ratio of the Aid flow (current US$) of Mexico in 2006 to that in 2011?
Your response must be concise. 0.2. What is the ratio of the Aid flow (current US$) of Montenegro in 2006 to that in 2011?
Your answer should be compact. 0.24. What is the ratio of the Aid flow (current US$) in Niger in 2006 to that in 2011?
Your response must be concise. 0.64. What is the ratio of the Aid flow (current US$) of Heavily indebted poor countries in 2006 to that in 2012?
Keep it short and to the point. 0.84. What is the ratio of the Aid flow (current US$) of Mexico in 2006 to that in 2012?
Your response must be concise. 0.86. What is the ratio of the Aid flow (current US$) of Montenegro in 2006 to that in 2012?
Provide a succinct answer. 0.37. What is the ratio of the Aid flow (current US$) in Niger in 2006 to that in 2012?
Give a very brief answer. 0.39. What is the ratio of the Aid flow (current US$) of Heavily indebted poor countries in 2007 to that in 2008?
Your answer should be very brief. 0.86. What is the ratio of the Aid flow (current US$) of Mexico in 2007 to that in 2008?
Give a very brief answer. 0.5. What is the ratio of the Aid flow (current US$) of Montenegro in 2007 to that in 2008?
Your response must be concise. 3.32. What is the ratio of the Aid flow (current US$) in Niger in 2007 to that in 2008?
Keep it short and to the point. 0.75. What is the ratio of the Aid flow (current US$) of Heavily indebted poor countries in 2007 to that in 2009?
Offer a terse response. 0.97. What is the ratio of the Aid flow (current US$) in Mexico in 2007 to that in 2009?
Provide a short and direct response. 1.79. What is the ratio of the Aid flow (current US$) of Montenegro in 2007 to that in 2009?
Give a very brief answer. 2.11. What is the ratio of the Aid flow (current US$) in Niger in 2007 to that in 2009?
Make the answer very short. 1.78. What is the ratio of the Aid flow (current US$) of Heavily indebted poor countries in 2007 to that in 2010?
Make the answer very short. 0.9. What is the ratio of the Aid flow (current US$) of Mexico in 2007 to that in 2010?
Your answer should be compact. 1.45. What is the ratio of the Aid flow (current US$) in Montenegro in 2007 to that in 2010?
Give a very brief answer. 2.3. What is the ratio of the Aid flow (current US$) in Niger in 2007 to that in 2010?
Ensure brevity in your answer.  0.76. What is the ratio of the Aid flow (current US$) of Heavily indebted poor countries in 2007 to that in 2011?
Offer a terse response. 1.01. What is the ratio of the Aid flow (current US$) in Mexico in 2007 to that in 2011?
Your answer should be very brief. 0.13. What is the ratio of the Aid flow (current US$) of Montenegro in 2007 to that in 2011?
Provide a short and direct response. 0.42. What is the ratio of the Aid flow (current US$) in Niger in 2007 to that in 2011?
Your response must be concise. 0.85. What is the ratio of the Aid flow (current US$) in Heavily indebted poor countries in 2007 to that in 2012?
Give a very brief answer. 1.02. What is the ratio of the Aid flow (current US$) of Mexico in 2007 to that in 2012?
Provide a short and direct response. 0.54. What is the ratio of the Aid flow (current US$) of Montenegro in 2007 to that in 2012?
Keep it short and to the point. 0.64. What is the ratio of the Aid flow (current US$) in Niger in 2007 to that in 2012?
Give a very brief answer. 0.51. What is the ratio of the Aid flow (current US$) in Heavily indebted poor countries in 2008 to that in 2009?
Your answer should be very brief. 1.12. What is the ratio of the Aid flow (current US$) in Mexico in 2008 to that in 2009?
Ensure brevity in your answer.  3.57. What is the ratio of the Aid flow (current US$) in Montenegro in 2008 to that in 2009?
Provide a short and direct response. 0.63. What is the ratio of the Aid flow (current US$) in Niger in 2008 to that in 2009?
Your answer should be very brief. 2.37. What is the ratio of the Aid flow (current US$) of Heavily indebted poor countries in 2008 to that in 2010?
Make the answer very short. 1.04. What is the ratio of the Aid flow (current US$) of Mexico in 2008 to that in 2010?
Keep it short and to the point. 2.89. What is the ratio of the Aid flow (current US$) of Montenegro in 2008 to that in 2010?
Your answer should be very brief. 0.69. What is the ratio of the Aid flow (current US$) in Niger in 2008 to that in 2010?
Keep it short and to the point. 1.01. What is the ratio of the Aid flow (current US$) in Heavily indebted poor countries in 2008 to that in 2011?
Give a very brief answer. 1.17. What is the ratio of the Aid flow (current US$) of Mexico in 2008 to that in 2011?
Your response must be concise. 0.25. What is the ratio of the Aid flow (current US$) of Montenegro in 2008 to that in 2011?
Offer a terse response. 0.13. What is the ratio of the Aid flow (current US$) of Niger in 2008 to that in 2011?
Keep it short and to the point. 1.13. What is the ratio of the Aid flow (current US$) of Heavily indebted poor countries in 2008 to that in 2012?
Make the answer very short. 1.19. What is the ratio of the Aid flow (current US$) of Mexico in 2008 to that in 2012?
Your response must be concise. 1.08. What is the ratio of the Aid flow (current US$) of Montenegro in 2008 to that in 2012?
Provide a short and direct response. 0.19. What is the ratio of the Aid flow (current US$) in Niger in 2008 to that in 2012?
Give a very brief answer. 0.68. What is the ratio of the Aid flow (current US$) in Heavily indebted poor countries in 2009 to that in 2010?
Your response must be concise. 0.93. What is the ratio of the Aid flow (current US$) of Mexico in 2009 to that in 2010?
Ensure brevity in your answer.  0.81. What is the ratio of the Aid flow (current US$) of Montenegro in 2009 to that in 2010?
Keep it short and to the point. 1.09. What is the ratio of the Aid flow (current US$) of Niger in 2009 to that in 2010?
Give a very brief answer. 0.43. What is the ratio of the Aid flow (current US$) in Heavily indebted poor countries in 2009 to that in 2011?
Your answer should be compact. 1.04. What is the ratio of the Aid flow (current US$) of Mexico in 2009 to that in 2011?
Give a very brief answer. 0.07. What is the ratio of the Aid flow (current US$) of Montenegro in 2009 to that in 2011?
Offer a terse response. 0.2. What is the ratio of the Aid flow (current US$) of Niger in 2009 to that in 2011?
Ensure brevity in your answer.  0.47. What is the ratio of the Aid flow (current US$) of Heavily indebted poor countries in 2009 to that in 2012?
Ensure brevity in your answer.  1.06. What is the ratio of the Aid flow (current US$) of Mexico in 2009 to that in 2012?
Offer a terse response. 0.3. What is the ratio of the Aid flow (current US$) of Montenegro in 2009 to that in 2012?
Offer a very short reply. 0.3. What is the ratio of the Aid flow (current US$) of Niger in 2009 to that in 2012?
Your answer should be compact. 0.29. What is the ratio of the Aid flow (current US$) of Heavily indebted poor countries in 2010 to that in 2011?
Your response must be concise. 1.12. What is the ratio of the Aid flow (current US$) of Mexico in 2010 to that in 2011?
Offer a terse response. 0.09. What is the ratio of the Aid flow (current US$) of Montenegro in 2010 to that in 2011?
Your answer should be compact. 0.18. What is the ratio of the Aid flow (current US$) of Niger in 2010 to that in 2011?
Make the answer very short. 1.11. What is the ratio of the Aid flow (current US$) in Heavily indebted poor countries in 2010 to that in 2012?
Provide a short and direct response. 1.14. What is the ratio of the Aid flow (current US$) in Mexico in 2010 to that in 2012?
Your answer should be compact. 0.37. What is the ratio of the Aid flow (current US$) in Montenegro in 2010 to that in 2012?
Provide a succinct answer. 0.28. What is the ratio of the Aid flow (current US$) of Niger in 2010 to that in 2012?
Keep it short and to the point. 0.67. What is the ratio of the Aid flow (current US$) of Heavily indebted poor countries in 2011 to that in 2012?
Give a very brief answer. 1.02. What is the ratio of the Aid flow (current US$) of Mexico in 2011 to that in 2012?
Your answer should be compact. 4.29. What is the ratio of the Aid flow (current US$) of Montenegro in 2011 to that in 2012?
Your answer should be compact. 1.52. What is the ratio of the Aid flow (current US$) of Niger in 2011 to that in 2012?
Ensure brevity in your answer.  0.61. What is the difference between the highest and the second highest Aid flow (current US$) in Heavily indebted poor countries?
Ensure brevity in your answer.  1.76e+08. What is the difference between the highest and the second highest Aid flow (current US$) of Mexico?
Offer a terse response. 6.47e+07. What is the difference between the highest and the second highest Aid flow (current US$) in Montenegro?
Give a very brief answer. 2.56e+07. What is the difference between the highest and the second highest Aid flow (current US$) in Niger?
Keep it short and to the point. 7.10e+07. What is the difference between the highest and the lowest Aid flow (current US$) in Heavily indebted poor countries?
Give a very brief answer. 1.31e+09. What is the difference between the highest and the lowest Aid flow (current US$) in Mexico?
Provide a short and direct response. 8.03e+07. What is the difference between the highest and the lowest Aid flow (current US$) in Montenegro?
Give a very brief answer. 6.52e+07. What is the difference between the highest and the lowest Aid flow (current US$) of Niger?
Your answer should be very brief. 1.59e+08. 